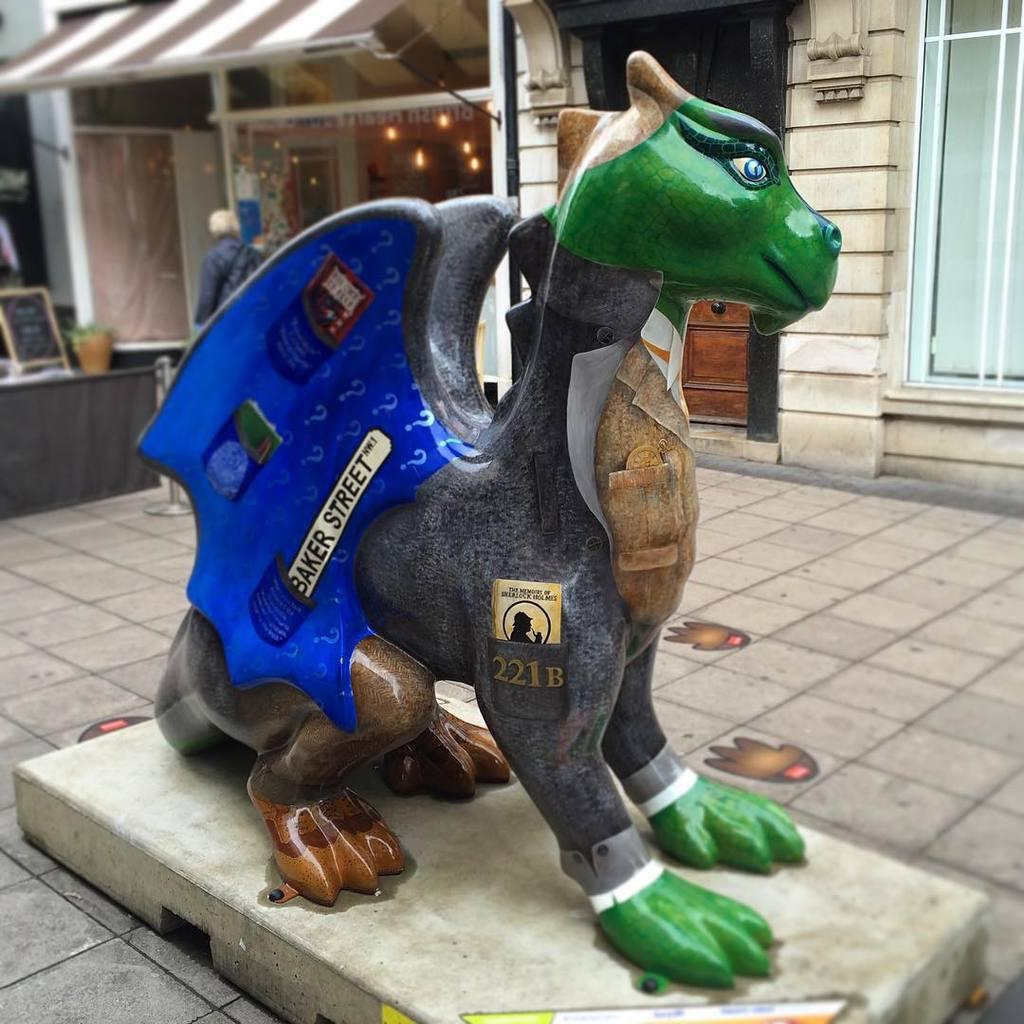What is the main subject in the foreground of the image? There is a statue in the image. What can be seen in the background of the image? There are buildings, lights, a board, a person, and other objects in the background of the image. Can you describe the buildings in the background? The provided facts do not give specific details about the buildings, so we cannot describe them. What type of zephyr is present in the image? There is no mention of a zephyr in the image, as it refers to a gentle breeze, which is not visible in a photograph. 